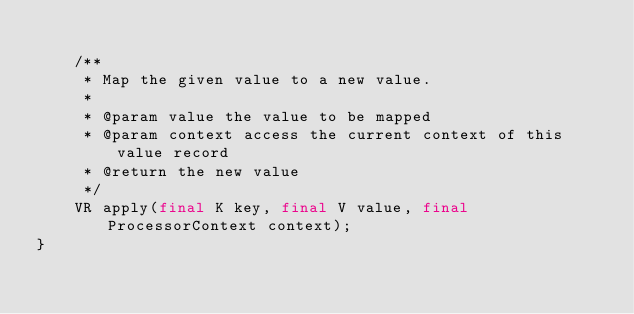Convert code to text. <code><loc_0><loc_0><loc_500><loc_500><_Java_>
    /**
     * Map the given value to a new value.
     *
     * @param value the value to be mapped
     * @param context access the current context of this value record
     * @return the new value
     */
    VR apply(final K key, final V value, final ProcessorContext context);
}

</code> 